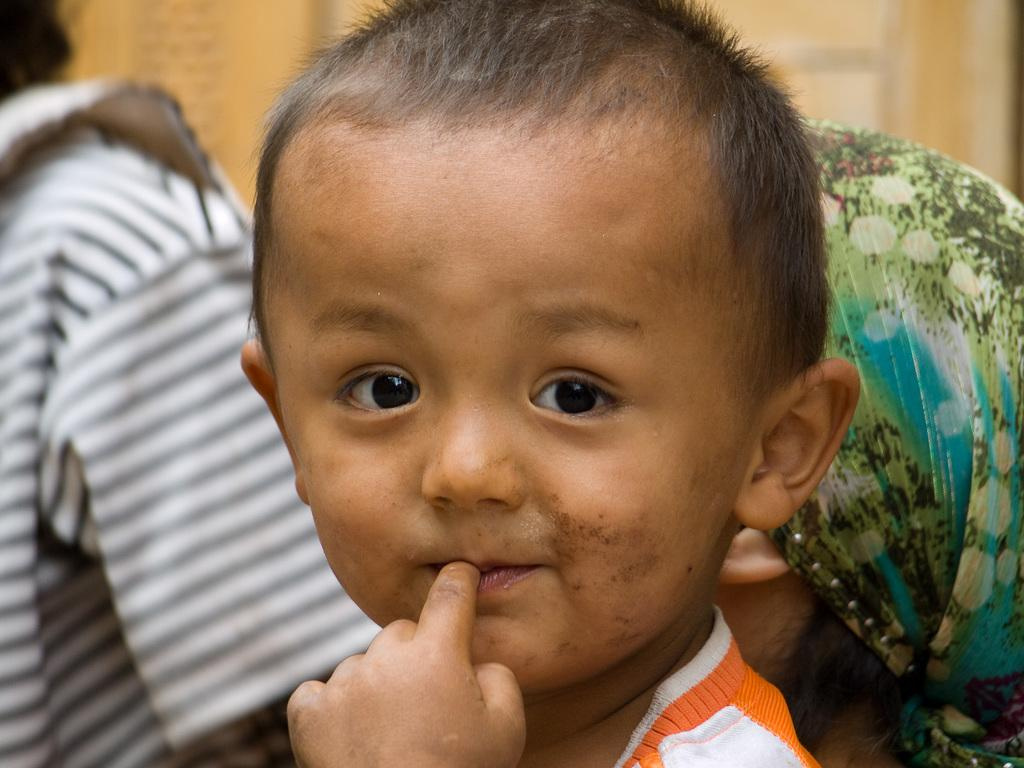What is the main subject of the image? There is a small kid in the image. Can you describe the people in the background? There are two persons in the background, one of whom is wearing a scarf on their head. How is the background of the image depicted? The background is blurred. What type of bee can be seen buzzing around the girl in the image? There is no bee present in the image, and the small kid in the image is not identified as a girl. 